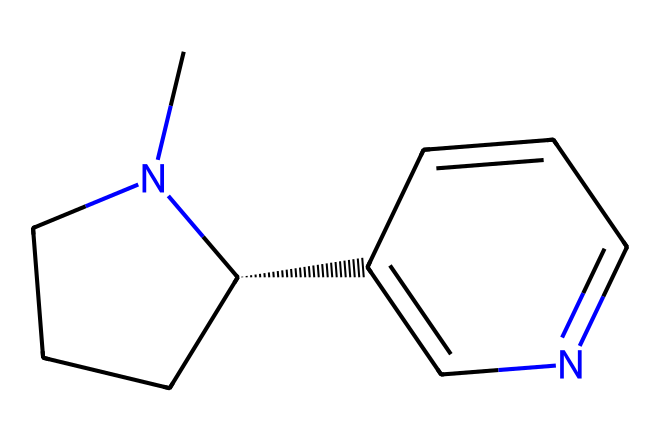What is the molecular formula of this chemical? To determine the molecular formula, we identify the atoms present in the structure. The provided SMILES indicates the presence of carbon (C), nitrogen (N), and hydrogen (H) atoms. By counting the number of atoms: there are 10 carbon atoms, 14 hydrogen atoms, and 2 nitrogen atoms. Therefore, the molecular formula combines these counts to yield C10H14N2.
Answer: C10H14N2 How many rings are present in this chemical structure? By analyzing the SMILES representation, we can identify the cyclic nature of the molecule. The use of '1' in the SMILES indicates the presence of a ring structure. Upon inspection, there are two numbered indicators, suggesting that there are two connected cyclic structures. Thus, the total number of rings is two.
Answer: 2 What are the functional groups in this chemical? By examining the structural elements in the SMILES, we note the presence of the nitrogen atoms within the rings. This indicates the presence of an amine functional group. Additionally, the structure suggests that it could be classified as an alkaloid due to the cyclic nature and nitrogen atoms. Thus, the main functional group is the amine group in the context of this compound.
Answer: amine What type of molecular interaction can this chemical likely participate in? The presence of nitrogen atoms suggests that this molecule can engage in hydrogen bonding due to the basic nature of the nitrogen atom. The amine group can donate a hydrogen atom to form hydrogen bonds with other electronegative atoms or functional groups, indicating that intermolecular hydrogen bonding is likely.
Answer: hydrogen bonding Is this chemical polar or nonpolar? To assess the polarity of this molecule, we look at the distribution of electronegative atoms and the overall shape. The presence of nitrogen atoms introduces partial charges, and the structure indicates some degree of symmetry. However, due to the nitrogen atoms and their potential for interacting with water, the molecule is primarily polar.
Answer: polar 